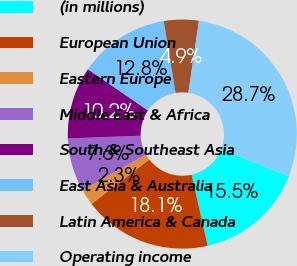<chart> <loc_0><loc_0><loc_500><loc_500><pie_chart><fcel>(in millions)<fcel>European Union<fcel>Eastern Europe<fcel>Middle East & Africa<fcel>South & Southeast Asia<fcel>East Asia & Australia<fcel>Latin America & Canada<fcel>Operating income<nl><fcel>15.47%<fcel>18.11%<fcel>2.27%<fcel>7.55%<fcel>10.19%<fcel>12.83%<fcel>4.91%<fcel>28.67%<nl></chart> 